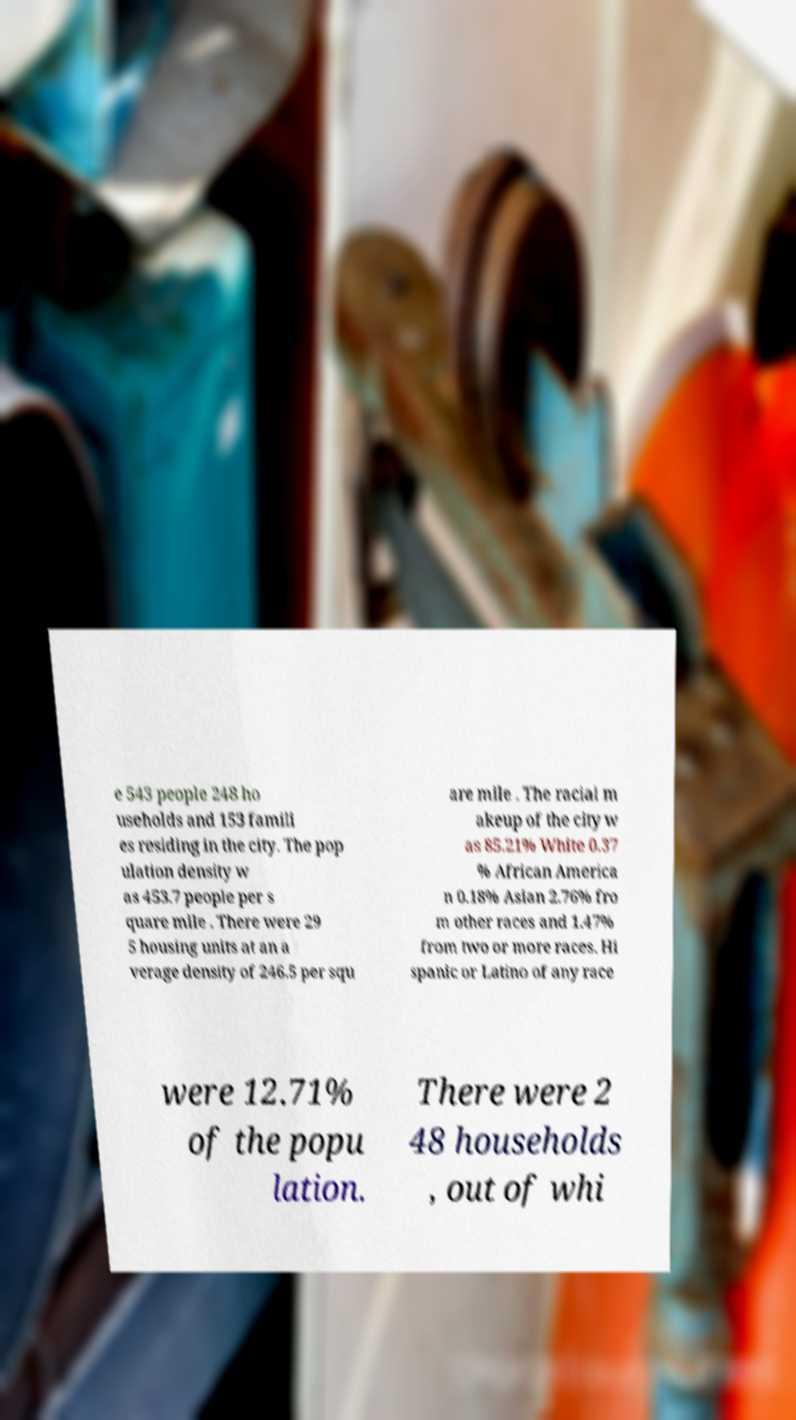There's text embedded in this image that I need extracted. Can you transcribe it verbatim? e 543 people 248 ho useholds and 153 famili es residing in the city. The pop ulation density w as 453.7 people per s quare mile . There were 29 5 housing units at an a verage density of 246.5 per squ are mile . The racial m akeup of the city w as 85.21% White 0.37 % African America n 0.18% Asian 2.76% fro m other races and 1.47% from two or more races. Hi spanic or Latino of any race were 12.71% of the popu lation. There were 2 48 households , out of whi 